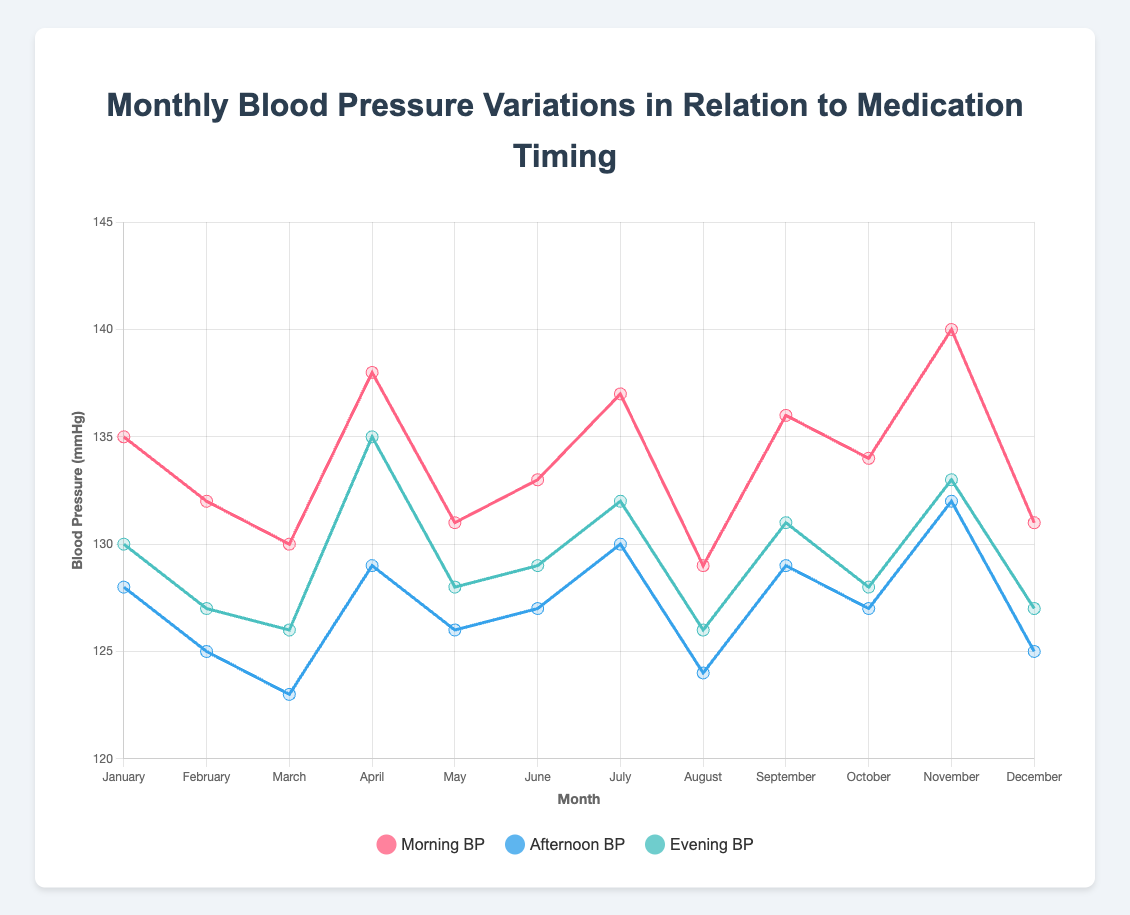What is the overall trend in morning blood pressure over the months? The morning blood pressure seems to fluctuate slightly but it generally trends downwards from January (135 mmHg) to August (129 mmHg), then fluctuates upwards toward November (140 mmHg).
Answer: The trend fluctuates Which month had the highest evening blood pressure? By looking at the 'Evening BP' data points, November had the highest evening blood pressure at 133 mmHg.
Answer: November In which month was the morning medication not taken despite a relatively high morning blood pressure? In March, morning blood pressure was at 130 mmHg and medication was not taken in the morning.
Answer: March How many months had a morning blood pressure higher than the afternoon blood pressure? Compare the morning and afternoon blood pressure for each month. January, February, April, May, June, July, September, October, November had morning BP higher than afternoon BP. That totals 9 months.
Answer: 9 months What's the sum of blood pressures in the evening for the first quarter of the year? Adding the evening BP for January (130), February (127), and March (126) results in 130 + 127 + 126 = 383 mmHg.
Answer: 383 mmHg Which month had the least variation between morning and evening blood pressure? Calculate the variation for each month (difference between morning BP and evening BP). August had the least variation of 3 (129 - 126).
Answer: August Does taking medication in the afternoon consistently result in a lower evening blood pressure? Check the pattern in months with medication taken in the afternoon (February, March, May, August, October, and December). Generally, the evening BP is relatively lower, indicating a likely trend.
Answer: Likely trend In which month was all BP measurements within 5 mmHg of each other? For May, the morning BP is 131, afternoon BP is 126, and evening BP is 128. None of the months have all three BPs within 5 mmHg of each other.
Answer: None Is there a clear visual difference in the blood pressure pattern between months when all medications were taken and months when not all medications were taken? Compare the months with all medications taken (May, October) to others. There is no stark visual difference in trends, but evening BP tends to be lower in months with all medications taken.
Answer: No stark visual difference When was the highest morning blood pressure recorded? The highest morning blood pressure (140 mmHg) was recorded in November.
Answer: November 